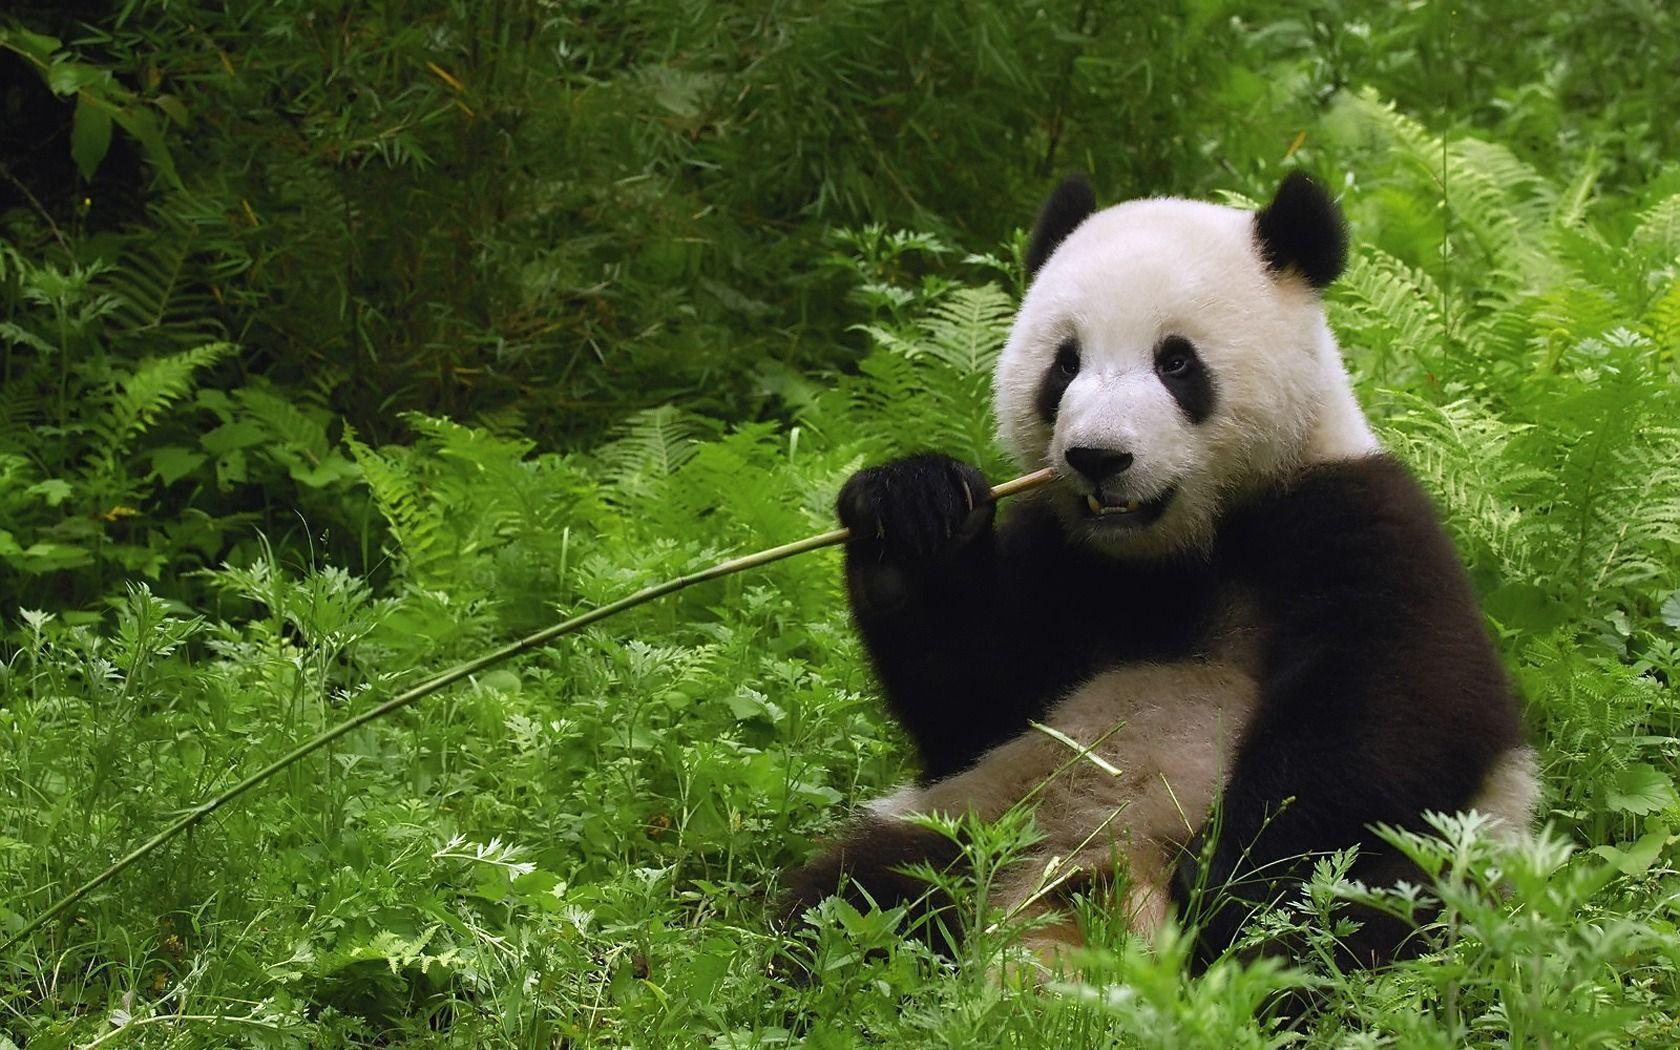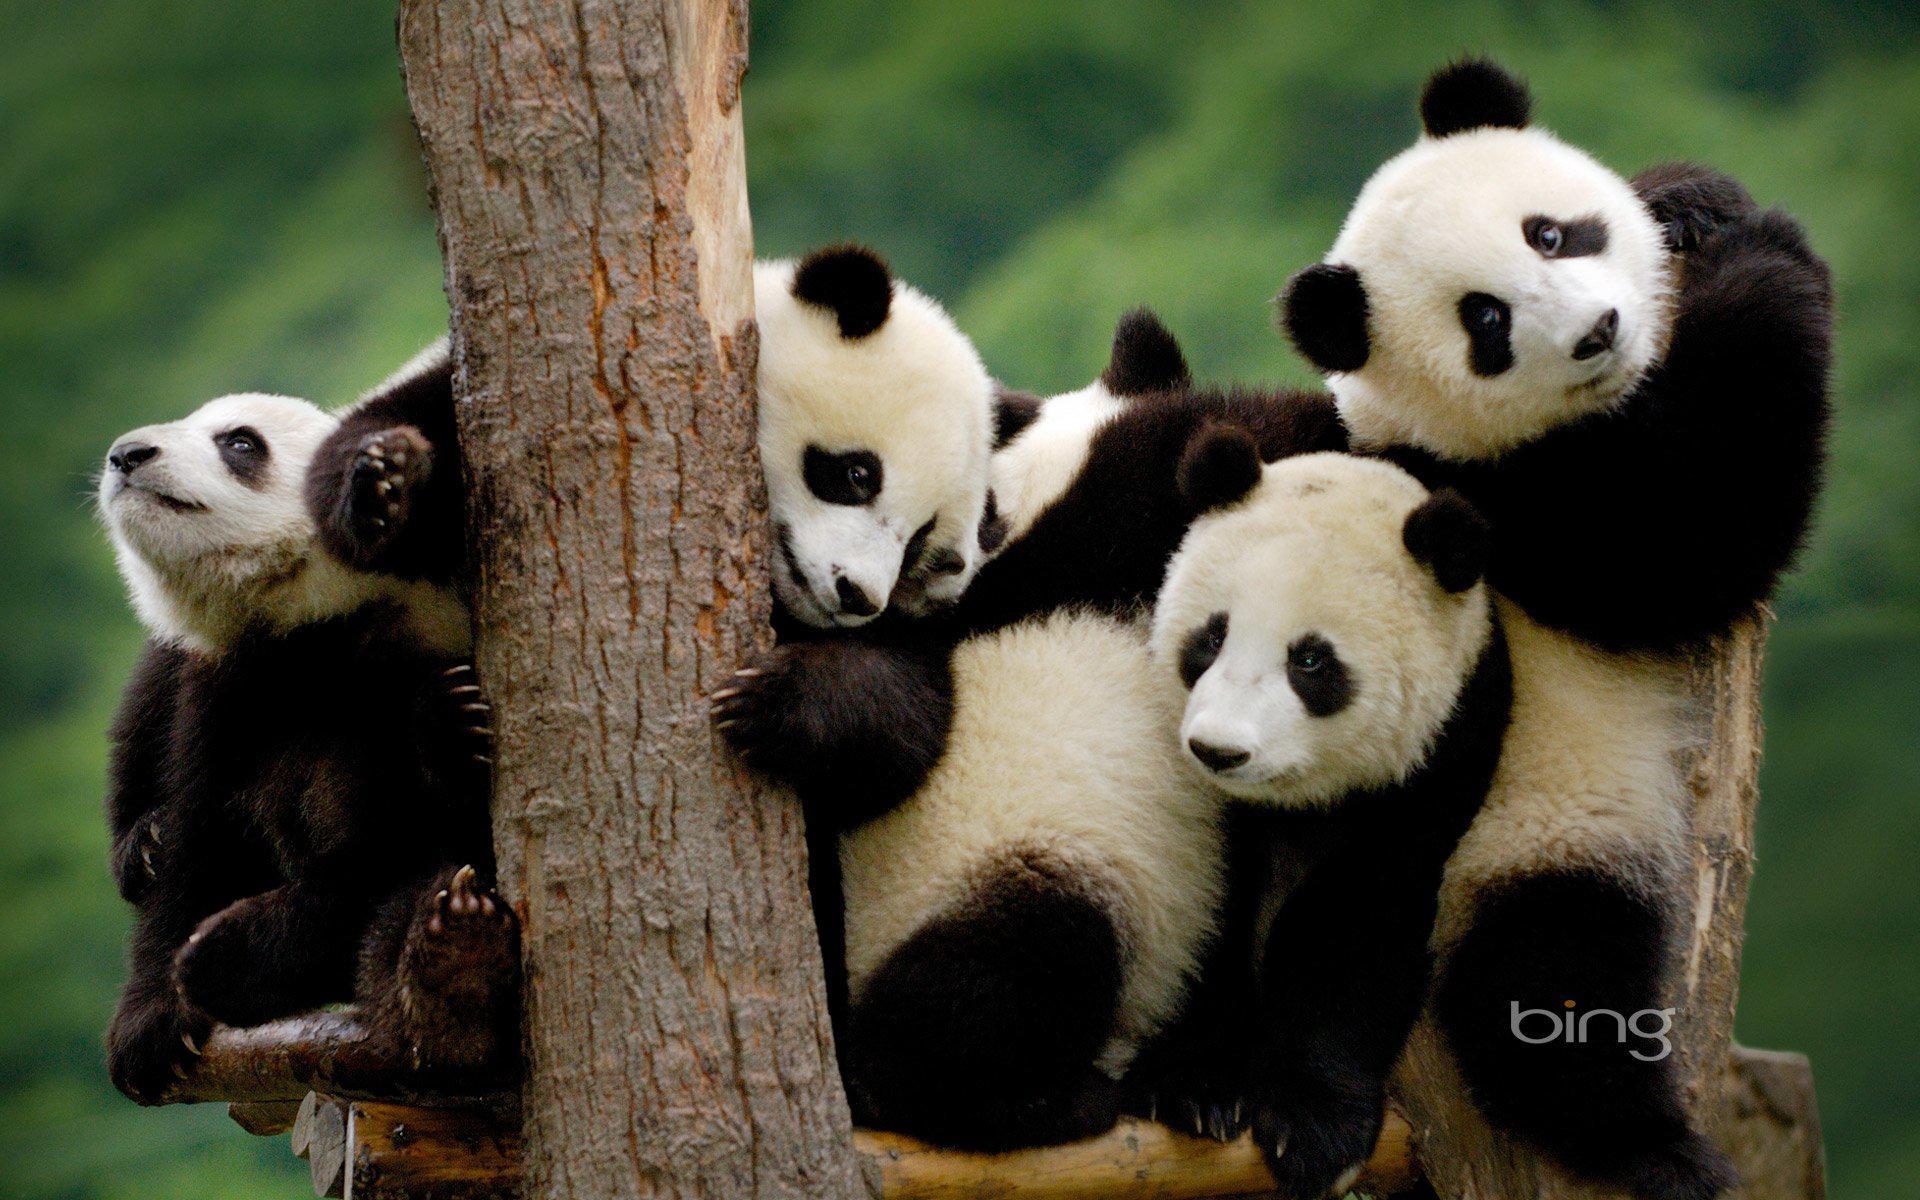The first image is the image on the left, the second image is the image on the right. Assess this claim about the two images: "The left and right image contains the same number of pandas.". Correct or not? Answer yes or no. No. 